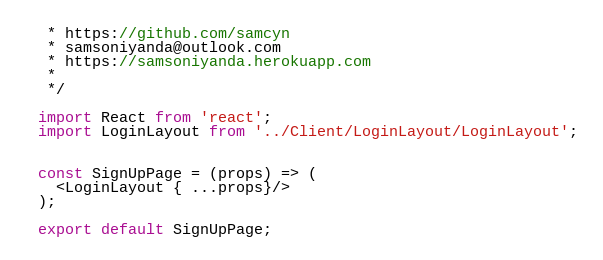Convert code to text. <code><loc_0><loc_0><loc_500><loc_500><_JavaScript_> * https://github.com/samcyn
 * samsoniyanda@outlook.com
 * https://samsoniyanda.herokuapp.com
 *
 */

import React from 'react';
import LoginLayout from '../Client/LoginLayout/LoginLayout';


const SignUpPage = (props) => (
  <LoginLayout { ...props}/>
);

export default SignUpPage;</code> 